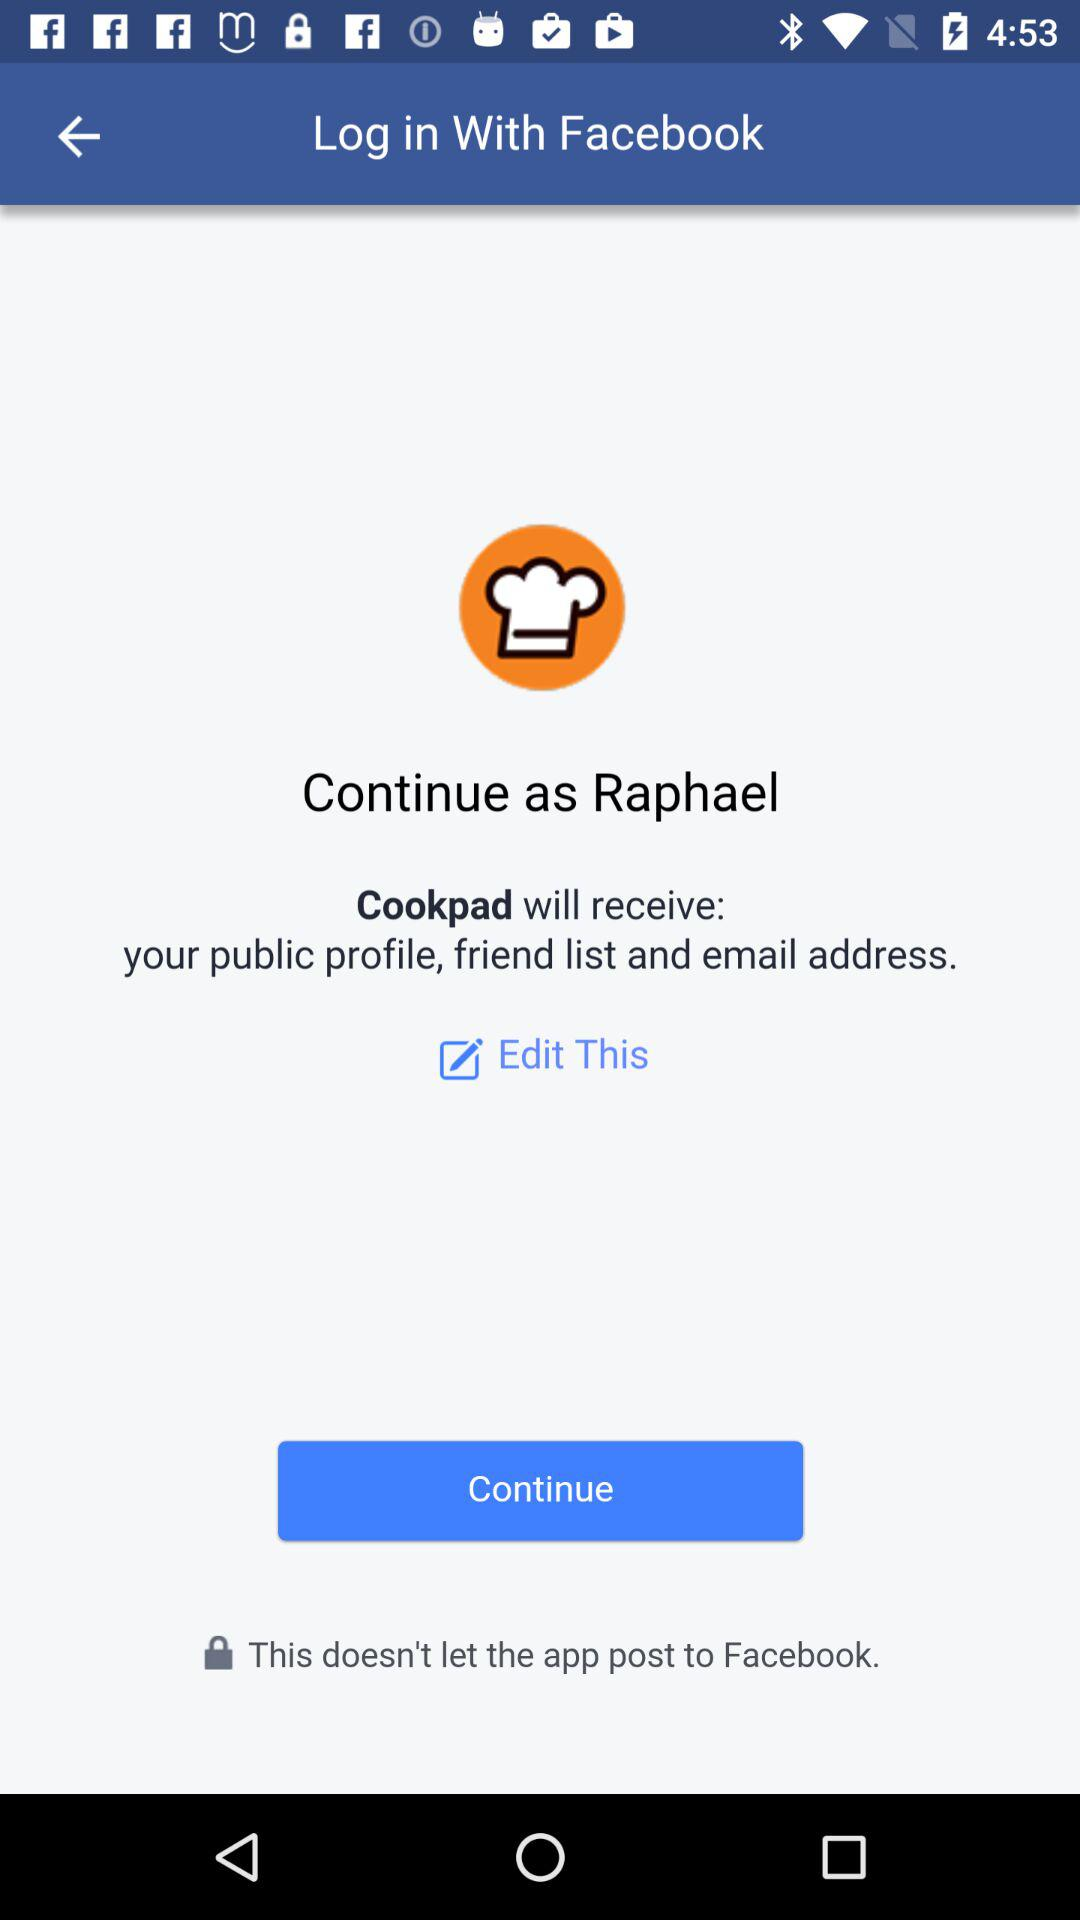What is the user name? The user name is Raphael. 